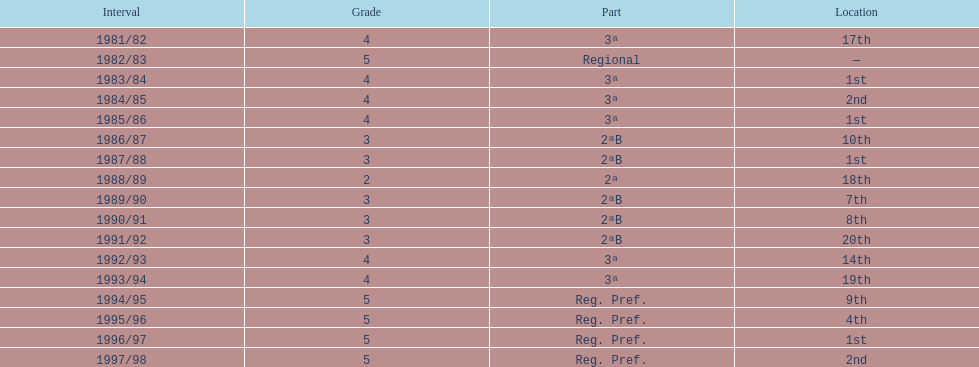What is the most recent year the team participated in division 2? 1991/92. 